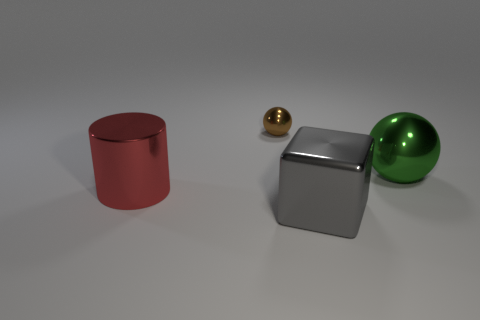Add 3 big red metallic cylinders. How many objects exist? 7 Subtract all metallic objects. Subtract all large matte cylinders. How many objects are left? 0 Add 3 tiny things. How many tiny things are left? 4 Add 2 big red shiny cylinders. How many big red shiny cylinders exist? 3 Subtract 1 gray cubes. How many objects are left? 3 